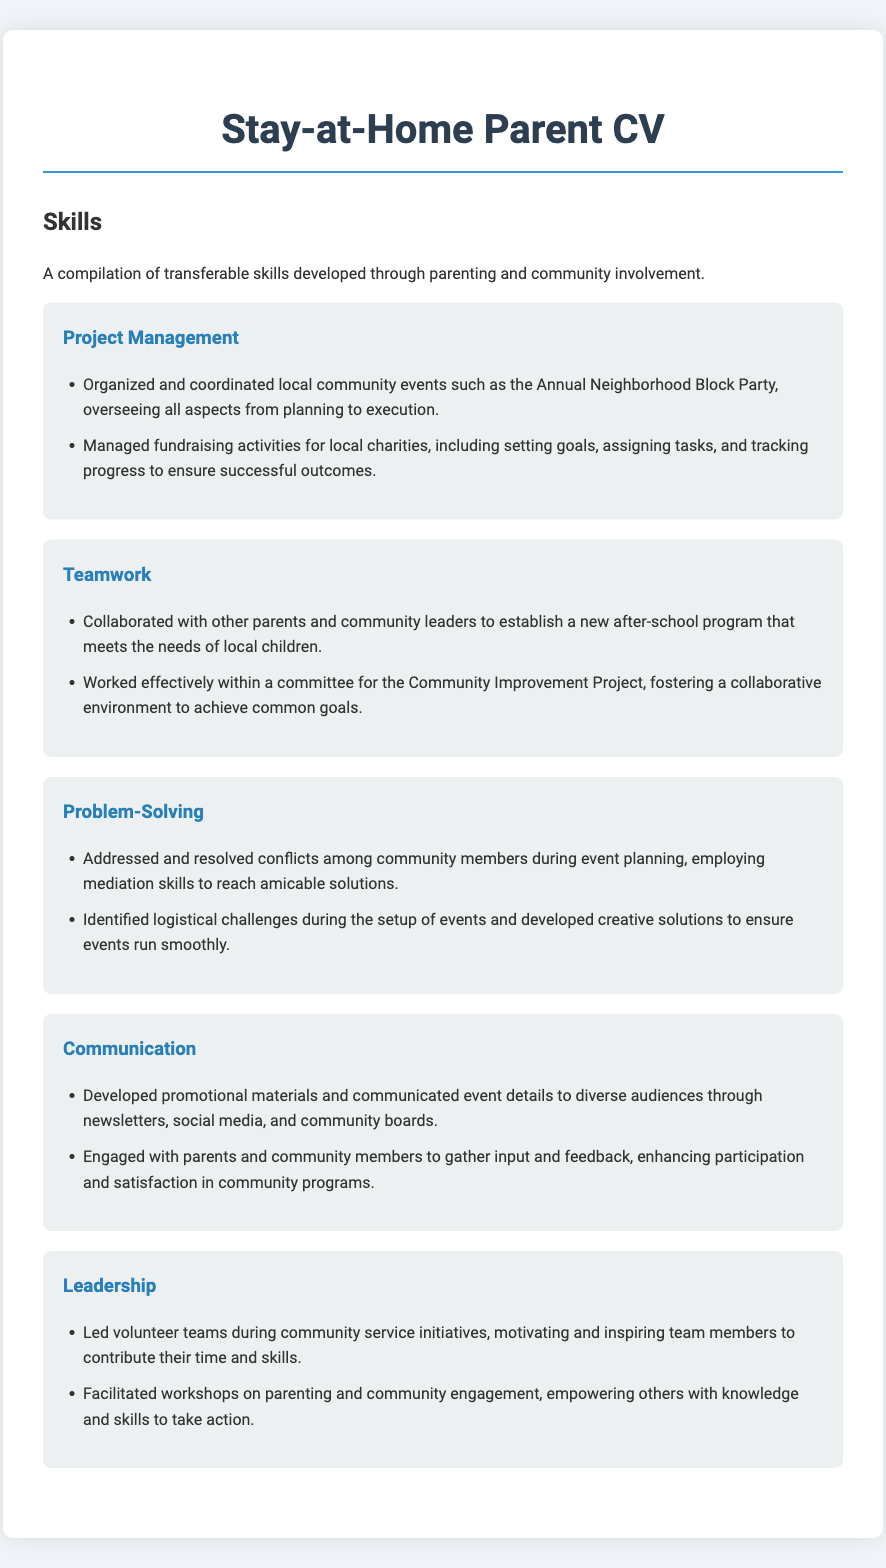What is one community event organized? The document lists the "Annual Neighborhood Block Party" as one of the events organized by the individual.
Answer: Annual Neighborhood Block Party What skill involves collaborating with others? The document mentions "Teamwork" as the skill associated with collaboration.
Answer: Teamwork How many fundraising activities are mentioned? The section on Project Management describes "fundraising activities" but does not specify a number, so it can be inferred that there are multiple activities.
Answer: Multiple What is a responsibility under Leadership? The document states that leading volunteer teams is one of the responsibilities under Leadership.
Answer: Led volunteer teams Which skill includes resolving conflicts? The problem-solving section highlights resolving conflicts among community members as part of the problem-solving skills.
Answer: Problem-Solving What is an example of communication efforts? The document states that one of the communication efforts was developing promotional materials to inform audiences.
Answer: Developing promotional materials What type of programs did the individual help establish? The individual helped establish an "after-school program" according to the Teamwork section.
Answer: After-school program Who were involved in the Community Improvement Project? The Community Improvement Project involved "other parents and community leaders."
Answer: Other parents and community leaders What skill is associated with addressing logistical challenges? The skill related to addressing logistical challenges is "Problem-Solving."
Answer: Problem-Solving 